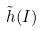Convert formula to latex. <formula><loc_0><loc_0><loc_500><loc_500>\tilde { h } ( I )</formula> 